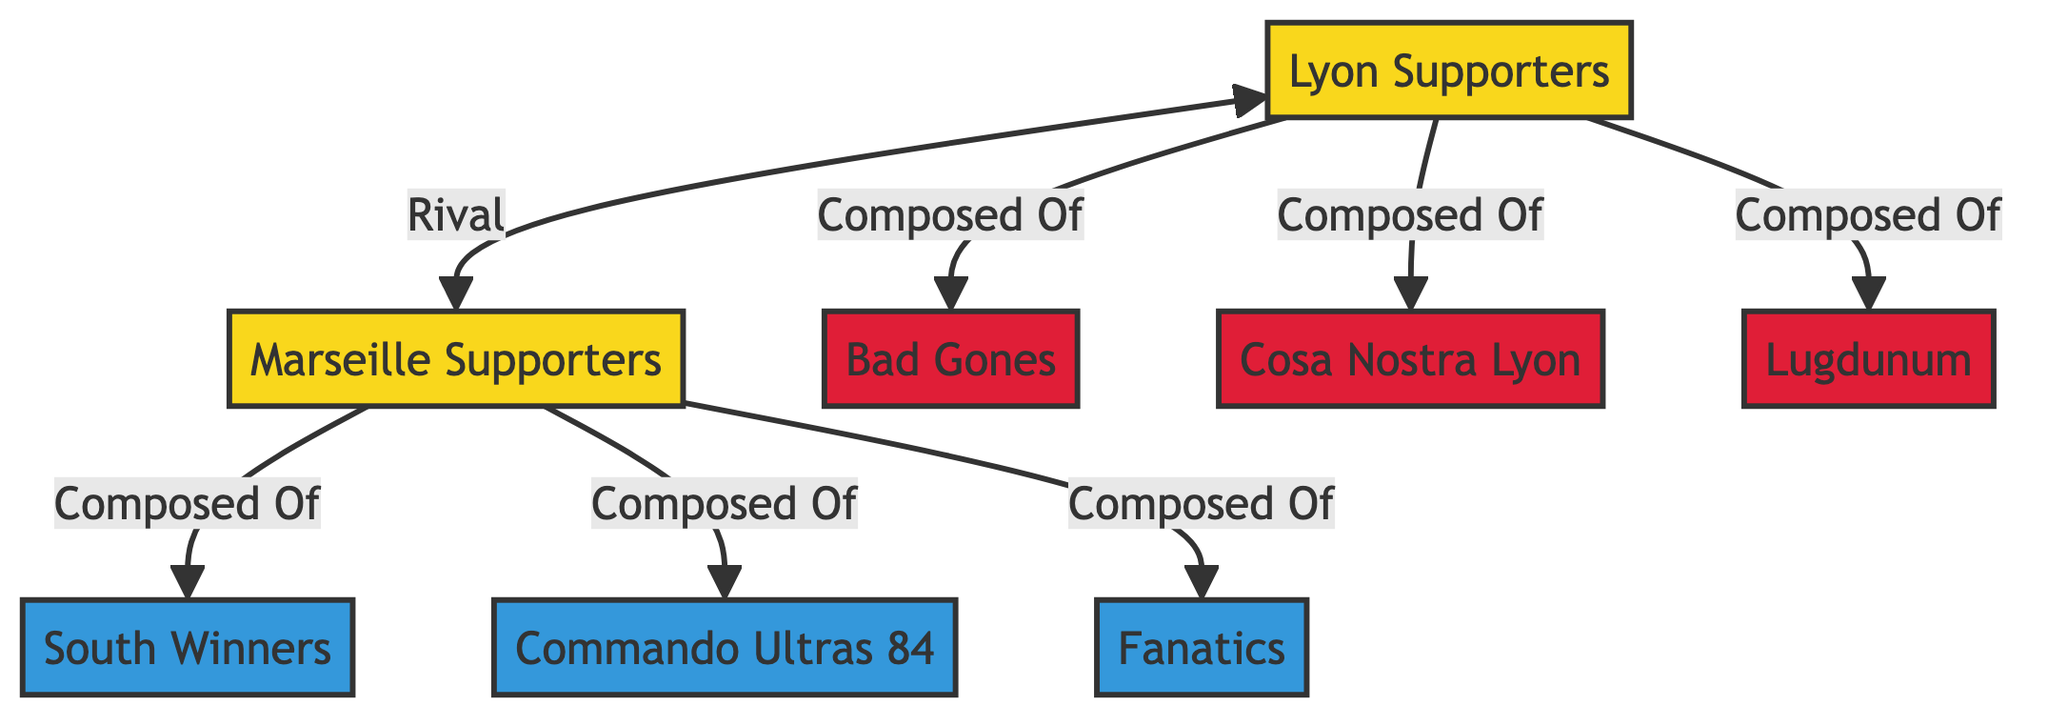What's the total number of supporter groups in the diagram? The diagram includes two main supporter groups: Lyon Supporters and Marseille Supporters.
Answer: 2 How many Lyon Ultras are represented in the diagram? There are three Lyon Ultras represented: Bad Gones, Cosa Nostra Lyon, and Lugdunum.
Answer: 3 Which group do the South Winners belong to? The South Winners are part of the Marseille Ultras, as indicated by their connection to the Marseille Supporters node.
Answer: Marseille Ultras What type of relationship exists between Lyon Supporters and Marseille Supporters? The relationship is labeled as "Rival," indicating a competitive connection between the two supporter groups.
Answer: Rival What are the names of the Lyon Ultras? The Lyon Ultras include Bad Gones, Cosa Nostra Lyon, and Lugdunum, which are all connected to the Lyon Supporters group.
Answer: Bad Gones, Cosa Nostra Lyon, Lugdunum How many direct connections does Marseille Supporters have? Marseille Supporters has three direct connections: to South Winners, Commando Ultras 84, and Fanatics.
Answer: 3 Which ultras group represents the Marseille supporters? The ultras group for the Marseille supporters is South Winners, Commando Ultras 84, and Fanatics, all connected to Marseille Supporters.
Answer: South Winners, Commando Ultras 84, Fanatics Which supporter group is composed of more subgroups, Lyon Supporters or Marseille Supporters? Lyon Supporters is composed of three subgroups (Bad Gones, Cosa Nostra Lyon, Lugdunum), while Marseille Supporters has three (South Winners, Commando Ultras 84, Fanatics). Both have equal compositions.
Answer: Equal What is the primary function of the links in this network diagram? The links illustrate the relationships between the nodes, showing how the supporter groups and ultras are interconnected and define their roles.
Answer: Relationships 